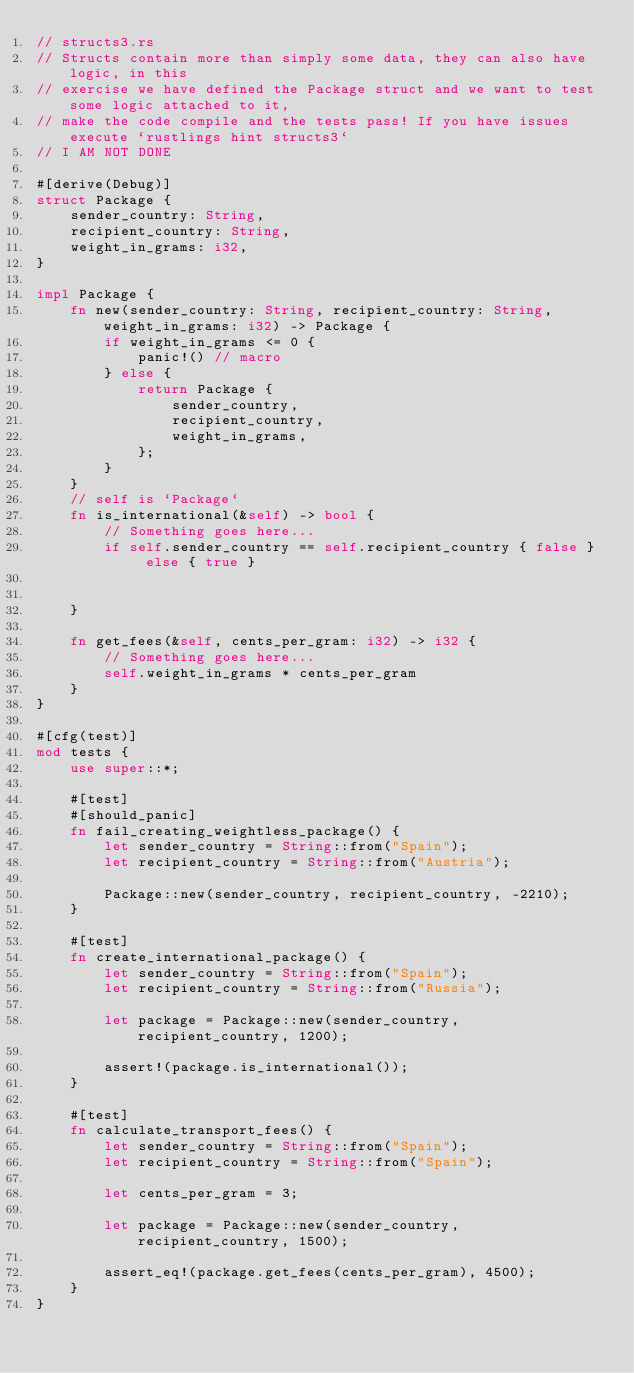Convert code to text. <code><loc_0><loc_0><loc_500><loc_500><_Rust_>// structs3.rs
// Structs contain more than simply some data, they can also have logic, in this
// exercise we have defined the Package struct and we want to test some logic attached to it,
// make the code compile and the tests pass! If you have issues execute `rustlings hint structs3`
// I AM NOT DONE

#[derive(Debug)]
struct Package {
    sender_country: String,
    recipient_country: String,
    weight_in_grams: i32,
}

impl Package {
    fn new(sender_country: String, recipient_country: String, weight_in_grams: i32) -> Package {
        if weight_in_grams <= 0 {
            panic!() // macro
        } else {
            return Package {
                sender_country,
                recipient_country,
                weight_in_grams,
            };
        }
    }
    // self is `Package`
    fn is_international(&self) -> bool {
        // Something goes here...
        if self.sender_country == self.recipient_country { false }  else { true }
        
        
    }

    fn get_fees(&self, cents_per_gram: i32) -> i32 {
        // Something goes here... 
        self.weight_in_grams * cents_per_gram
    }
}

#[cfg(test)]
mod tests {
    use super::*;

    #[test]
    #[should_panic]
    fn fail_creating_weightless_package() {
        let sender_country = String::from("Spain");
        let recipient_country = String::from("Austria");

        Package::new(sender_country, recipient_country, -2210);
    }

    #[test]
    fn create_international_package() {
        let sender_country = String::from("Spain");
        let recipient_country = String::from("Russia");

        let package = Package::new(sender_country, recipient_country, 1200);

        assert!(package.is_international());
    }

    #[test]
    fn calculate_transport_fees() {
        let sender_country = String::from("Spain");
        let recipient_country = String::from("Spain");

        let cents_per_gram = 3;

        let package = Package::new(sender_country, recipient_country, 1500);

        assert_eq!(package.get_fees(cents_per_gram), 4500);
    }
}
</code> 